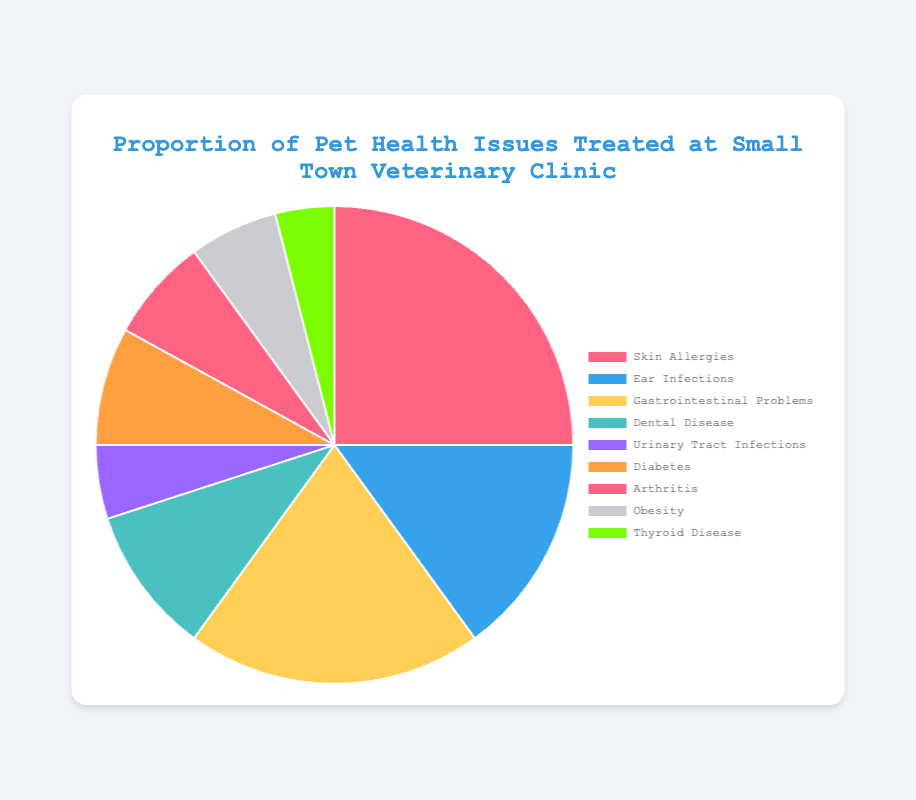Which health issue has the highest proportion? From the pie chart, the segment with the largest portion corresponds to 'Skin Allergies'.
Answer: Skin Allergies How much larger is the proportion of Skin Allergies compared to Ear Infections? 'Skin Allergies' has a proportion of 25%, while 'Ear Infections' has 15%. Subtracting these values gives 25% - 15% = 10%.
Answer: 10% What is the combined proportion of Urinary Tract Infections and Diabetes? Urinary Tract Infections have a proportion of 5% and Diabetes has 8%. Adding these values gives 5% + 8% = 13%.
Answer: 13% Which health issue appears least frequently in the data? The smallest segment in the pie chart is 'Thyroid Disease', with a proportion of 4%.
Answer: Thyroid Disease Are Dental Disease and Obesity equally represented? By looking at the pie chart, 'Dental Disease' has a proportion of 10%, and 'Obesity' has 6%. They are not equal.
Answer: No Which two health issues combined make up exactly 23% of the health issues treated? The combined proportion of 'Diabetes' and 'Arthritis' sums up to 8% + 7% = 15%. This is close but does not match. Trying with 'Urinary Tract Infections' (5%) and 'Obesity' (6%), these sum up to 11%, which is not correct either. The correct pair is 'Urinary Tract Infections' (5%) and 'Dental Disease' (10%), which add up to 15%. No combination exactly matches 23%.
Answer: None If we remove the top two health issues, what is the percentage of the remaining issues? 'Skin Allergies' (25%) and 'Gastrointestinal Problems' (20%) are the top two health issues. Removing their proportions from the total 100% leaves 55%.
Answer: 55% By how much does the proportion of Gastrointestinal Problems exceed that of Dental Disease? Gastrointestinal Problems have a proportion of 20%, and Dental Disease has 10%. Subtracting these gives 20% - 10% = 10%.
Answer: 10% What proportion of all health issues is represented by non-chronic conditions (diseases like Skin Allergies, Ear Infections, and Gastrointestinal Problems)? Adding the proportions of Skin Allergies (25%), Ear Infections (15%), and Gastrointestinal Problems (20%) gives 25% + 15% + 20% = 60%.
Answer: 60% 